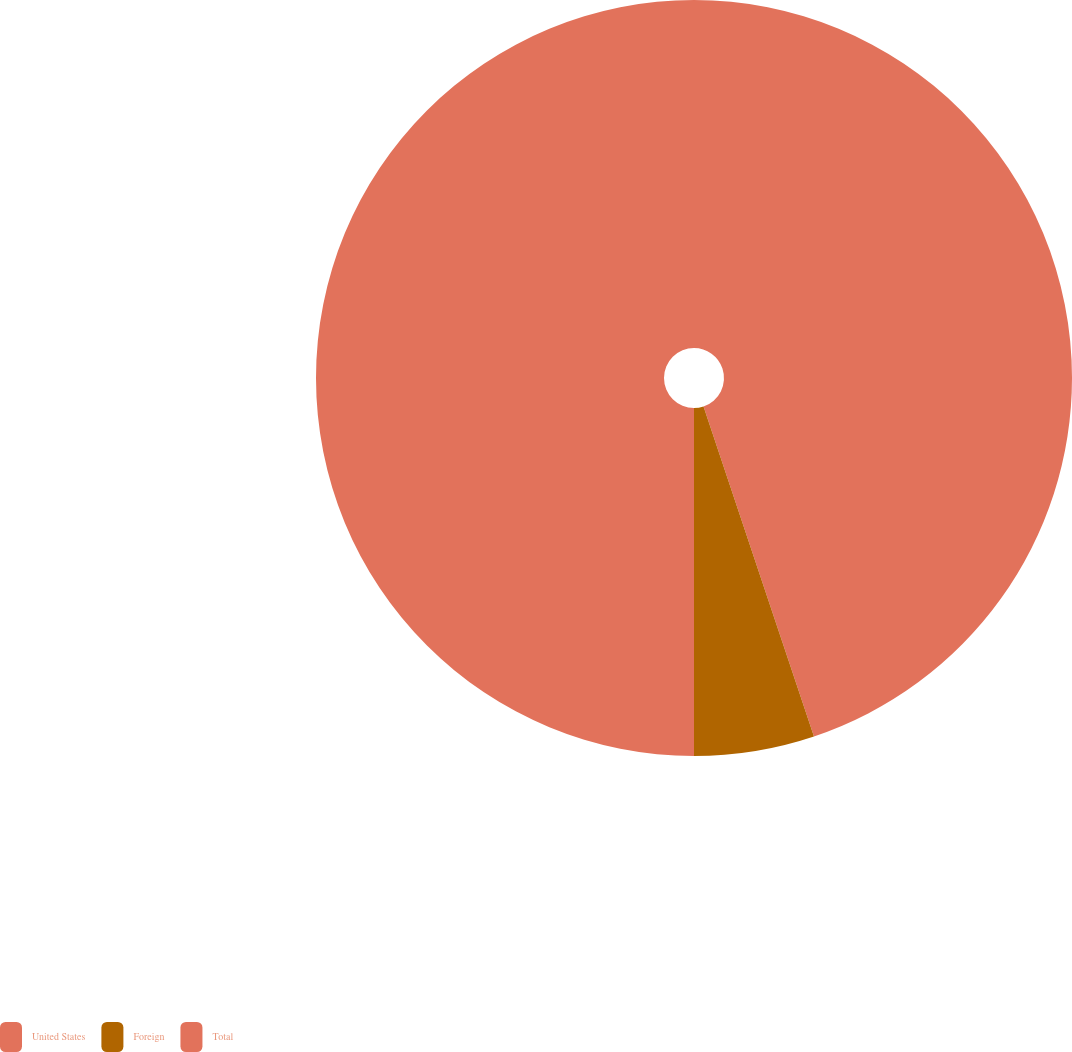Convert chart. <chart><loc_0><loc_0><loc_500><loc_500><pie_chart><fcel>United States<fcel>Foreign<fcel>Total<nl><fcel>44.86%<fcel>5.14%<fcel>50.0%<nl></chart> 